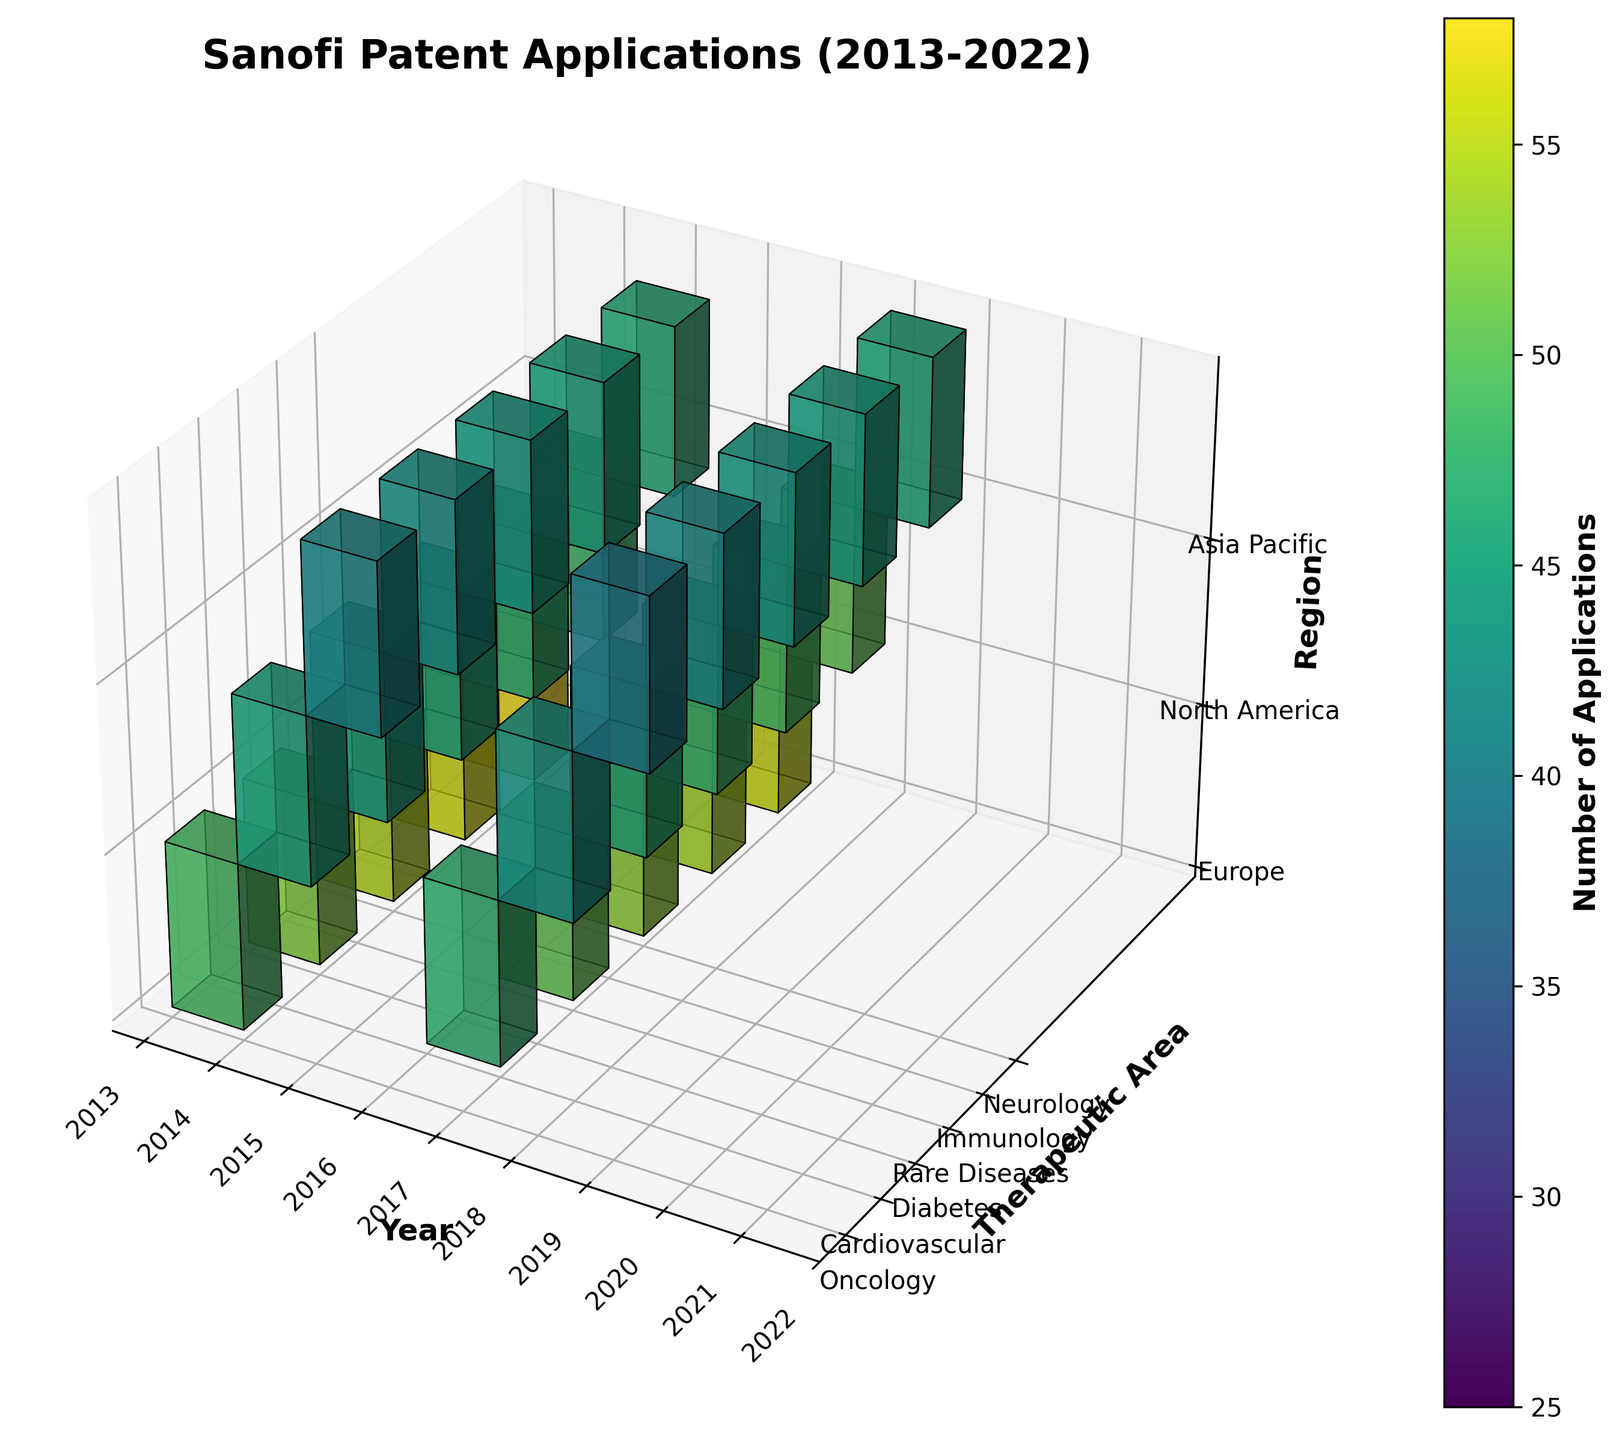what is the range of years covered in the figure? The years are displayed on the x-axis of the figure. They start in 2013 and go through to 2022, covering a decade.
Answer: 2013-2022 how many therapeutic areas are represented in the figure? The therapeutic areas are shown on the y-axis of the figure. By counting the labels, we see there are six therapeutic areas.
Answer: Six which year had the highest number of oncology patent applications in Europe? By observing the different color intensities in the 3D voxels for Europe in the Oncology row, the year with the brightest color, which represents the highest number of applications, is 2021.
Answer: 2021 what is the therapeutic area with the most patent applications in the most recent year? For the year 2022, we compare the colors in the various therapeutic areas. The brightest color represents the most patent applications. Rare Diseases have the brightest color.
Answer: Rare Diseases how does the number of cardiovascular patent applications in North America compare between 2013 and 2019? By comparing the color intensities of the 3D voxels for Cardiovascular in North America for the years 2013 and 2019, we see that the color for 2019 is brighter, indicating more applications than in 2013.
Answer: More in 2019 what is the total number of patent applications filed for Diabetes in Asia Pacific for the first and last year shown? Adding the numbers for Diabetes in Asia Pacific for 2013 (28 applications) and 2022 (36 applications) gives a total of 64 applications.
Answer: 64 how have patent applications in the Immunology therapeutic area evolved over the decade in North America? Analyzing the color changes for Immunology in North America from 2013 to 2022 shows a gradual increase in applications, as the colors become progressively brighter.
Answer: Gradual increase which region shows the highest number of patent applications in Neurology in the year 2020? For the year 2020, observing the color intensities in the Neurology row, Asia Pacific shows the brightest voxel, indicating the highest number of patent applications.
Answer: Asia Pacific what is the average number of patent applications filed in Europe each year for Rare Diseases? Aggregating the patent applications in Europe for Rare Diseases over the years (39 + 45 + 49 + 51 + 54) and dividing by the number of years (5) gives 238/5 = 47.6.
Answer: 47.6 